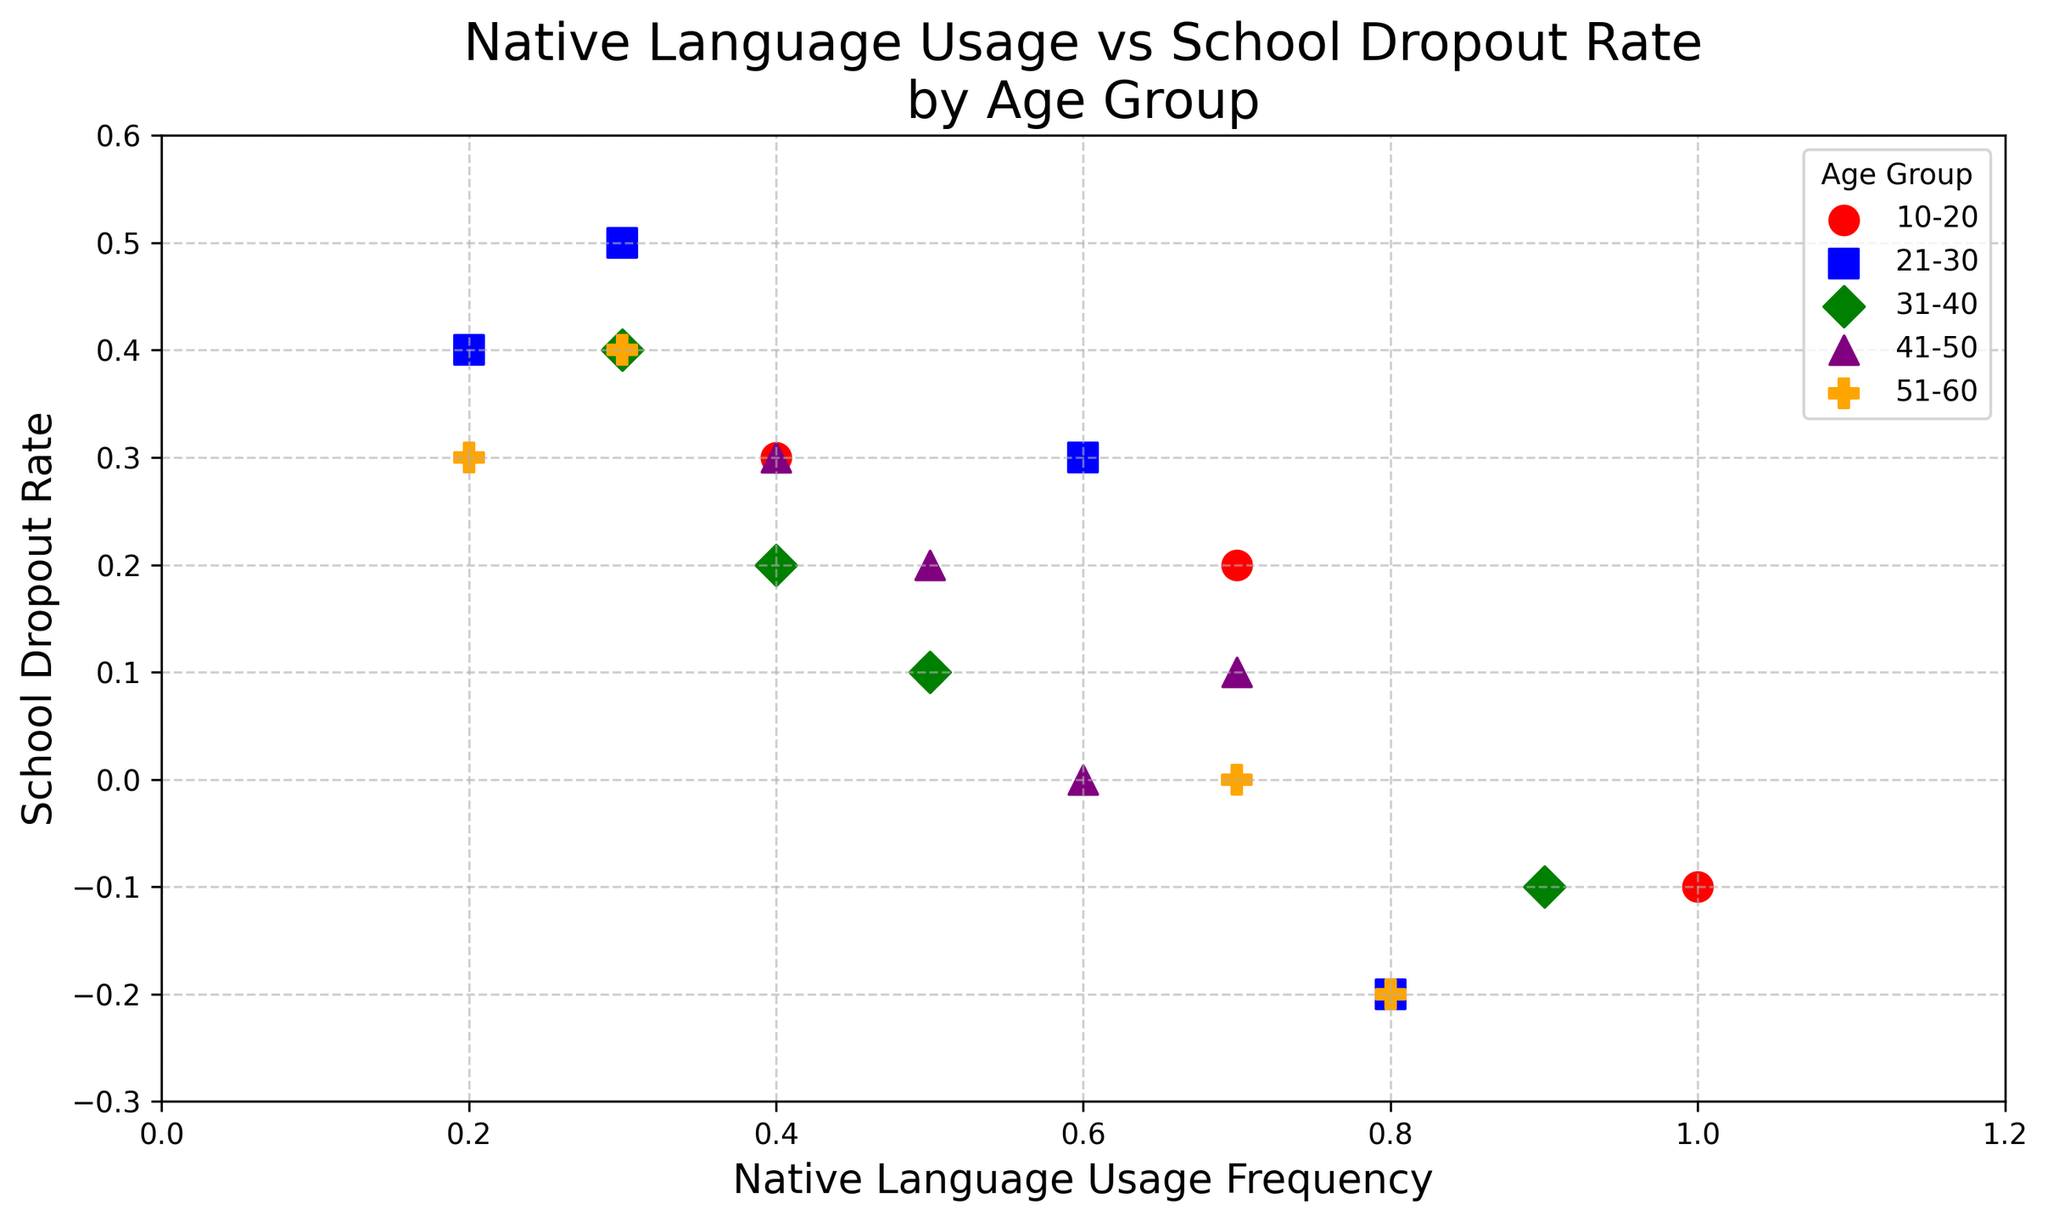What age group shows the highest frequency of native language usage? Check for the highest value in the "native language usage frequency" axis across all age groups. The highest value (1.0) occurs in the 10-20 age group.
Answer: 10-20 Are there any negative school dropout rates observed? If so, in which age groups? Look for points below the y-axis zero line. Negative dropout rates appear in age groups 10-20, 21-30, 31-40, and 51-60 due to some dots.
Answer: 10-20, 21-30, 31-40, 51-60 Which age group has the most diverse set of native language usage frequencies? Examine the spread of points along the x-axis for each age group (e.g., look at the range from minimum to maximum native language usage frequencies). The 21-30 age group shows the broadest range (0.2 to 0.8).
Answer: 21-30 For the age group 41-50, what's the average school dropout rate? Identify all school dropout rates for the 41-50 age group (0.3, 0.0, 0.1, 0.2). Average them by summing and dividing by the count: (0.3 + 0.0 + 0.1 + 0.2) / 4 = 0.15.
Answer: 0.15 Does higher native language usage frequency always correspond to lower school dropout rates? Observe all points and their relationship: while some points indicate low dropout with high frequency, others do not consistently show this trend.
Answer: Not always Which age group has the lowest average native language usage frequency? Calculate the average native language usage frequency for all age groups: 
- 10-20: (0.7 + 0.4 + 1.0 + 0.5) / 4 = 0.65
- 21-30: (0.2 + 0.8 + 0.3 + 0.6) / 4 = 0.475
- 31-40: (0.5 + 0.3 + 0.9 + 0.4) / 4 = 0.525
- 41-50: (0.4 + 0.6 + 0.7 + 0.5) / 4 = 0.55
- 51-60: (0.3 + 0.8 + 0.2 + 0.7) / 4 = 0.5
The lowest is 21-30 with 0.475.
Answer: 21-30 In the age group 21-30, what's the difference between the highest and the lowest school dropout rates? Identify the dropout rates for 21-30 (0.4, -0.2, 0.5, 0.3). The highest is 0.5, and the lowest is -0.2. The difference is 0.5 - (-0.2) = 0.7.
Answer: 0.7 